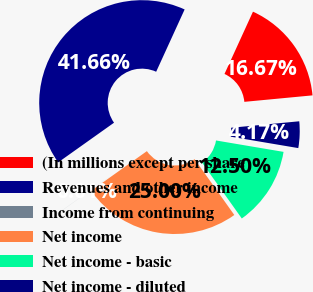<chart> <loc_0><loc_0><loc_500><loc_500><pie_chart><fcel>(In millions except per share<fcel>Revenues and other income<fcel>Income from continuing<fcel>Net income<fcel>Net income - basic<fcel>Net income - diluted<nl><fcel>16.67%<fcel>41.66%<fcel>0.01%<fcel>25.0%<fcel>12.5%<fcel>4.17%<nl></chart> 